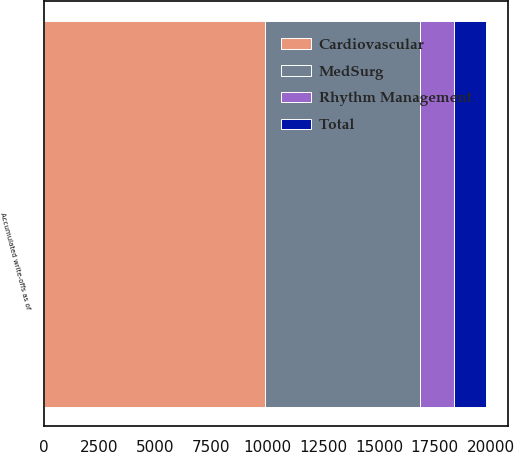<chart> <loc_0><loc_0><loc_500><loc_500><stacked_bar_chart><ecel><fcel>Accumulated write-offs as of<nl><fcel>Rhythm Management<fcel>1479<nl><fcel>MedSurg<fcel>6960<nl><fcel>Total<fcel>1461<nl><fcel>Cardiovascular<fcel>9900<nl></chart> 